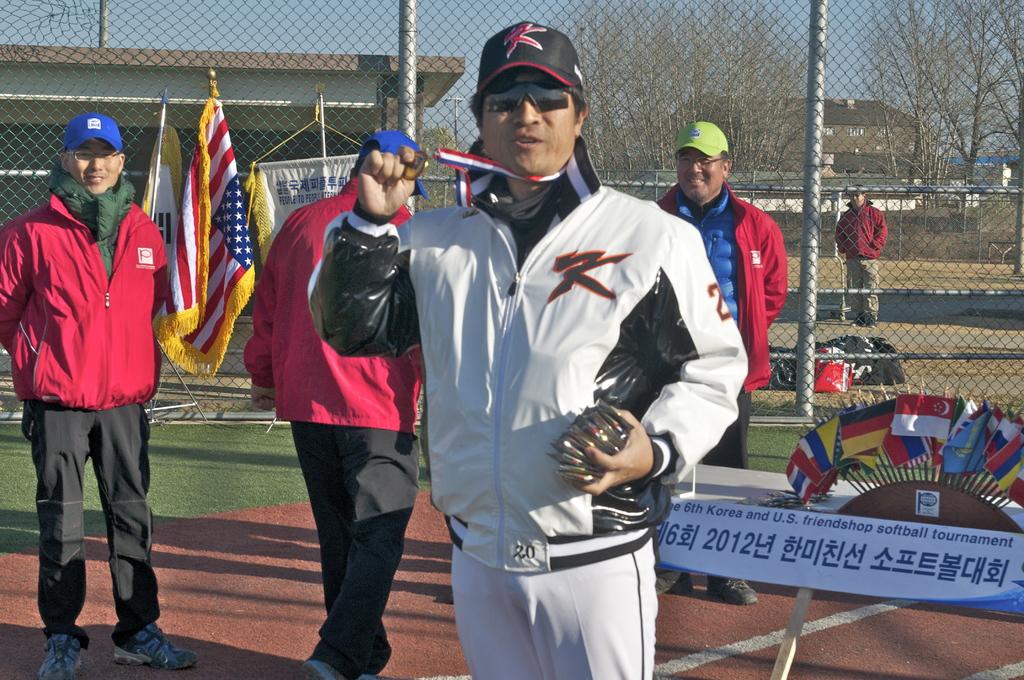What language do they most likely speak?
Offer a very short reply. Unanswerable. What year was this taken?
Provide a succinct answer. 2012. 